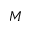<formula> <loc_0><loc_0><loc_500><loc_500>M</formula> 